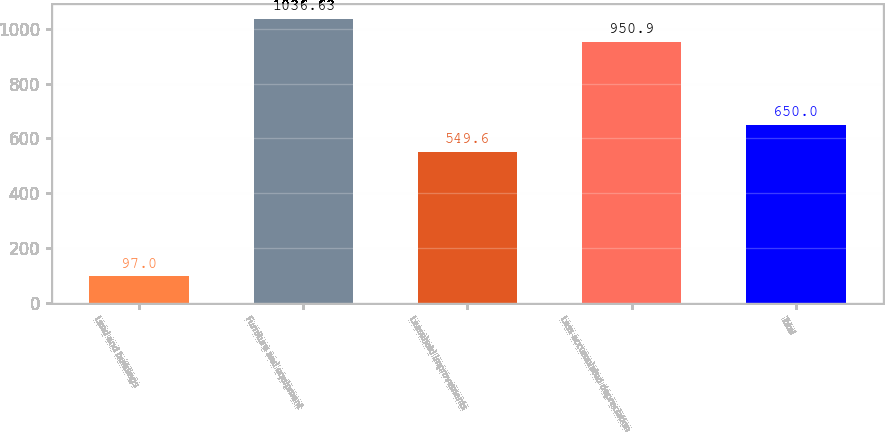<chart> <loc_0><loc_0><loc_500><loc_500><bar_chart><fcel>Land and buildings<fcel>Furniture and equipment<fcel>Leasehold improvements<fcel>Less accumulated depreciation<fcel>Total<nl><fcel>97<fcel>1036.63<fcel>549.6<fcel>950.9<fcel>650<nl></chart> 